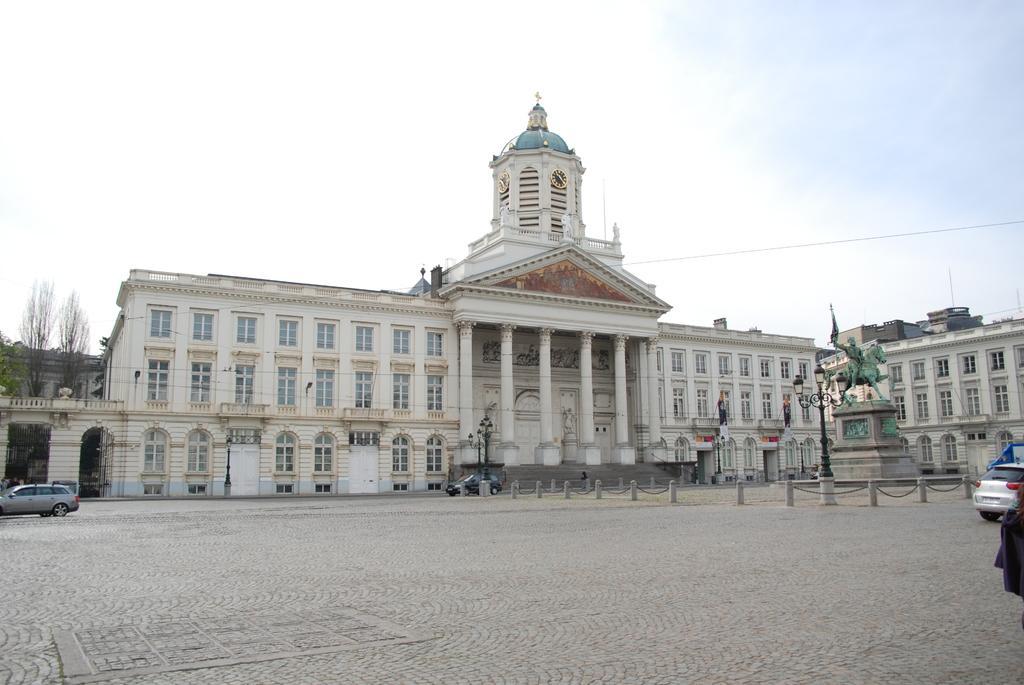Please provide a concise description of this image. In the image there is a building with walls, windows, pillars, roofs and also there is clock. In front of the building there are steps. There is a statue of a person sitting on the horse. Around the statue there is a fencing of poles with chains. On the ground there are cars. On the left side of the image behind the walls there are trees. At the top of the image there is sky. 